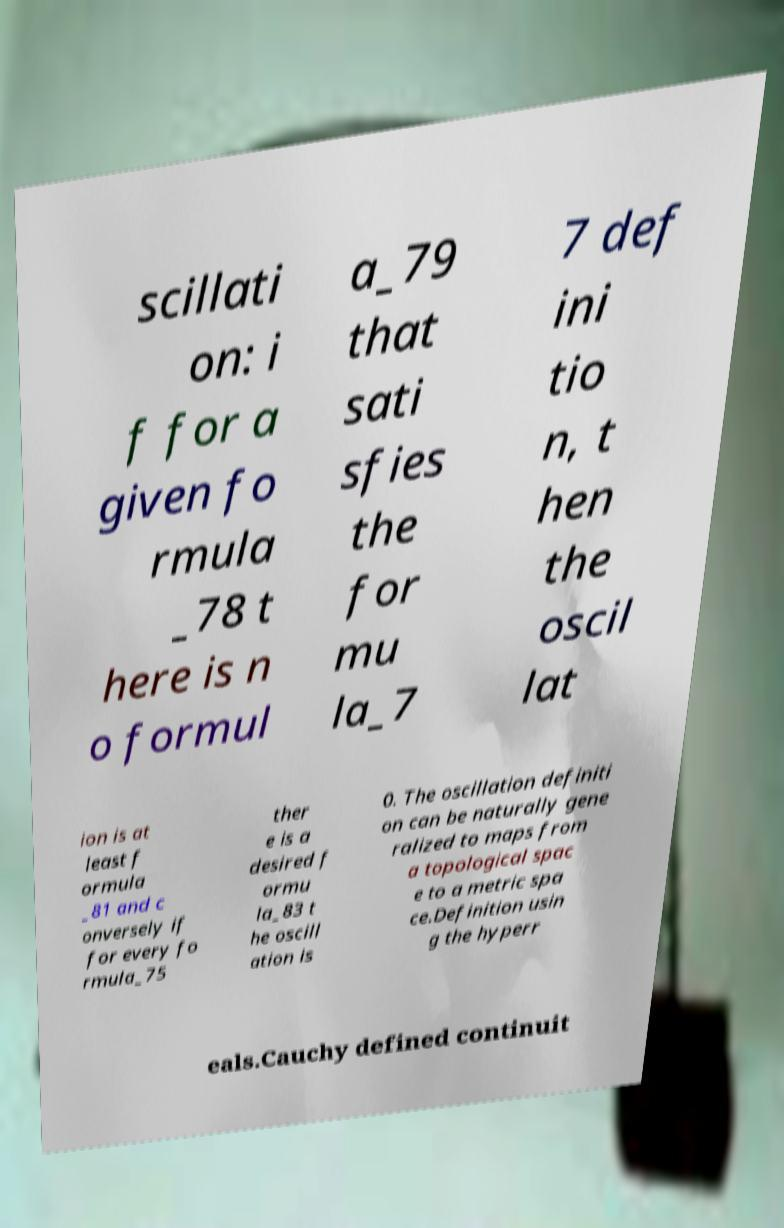For documentation purposes, I need the text within this image transcribed. Could you provide that? scillati on: i f for a given fo rmula _78 t here is n o formul a_79 that sati sfies the for mu la_7 7 def ini tio n, t hen the oscil lat ion is at least f ormula _81 and c onversely if for every fo rmula_75 ther e is a desired f ormu la_83 t he oscill ation is 0. The oscillation definiti on can be naturally gene ralized to maps from a topological spac e to a metric spa ce.Definition usin g the hyperr eals.Cauchy defined continuit 